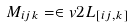<formula> <loc_0><loc_0><loc_500><loc_500>M _ { i j k } = \in v { 2 } L _ { [ i j , k ] }</formula> 